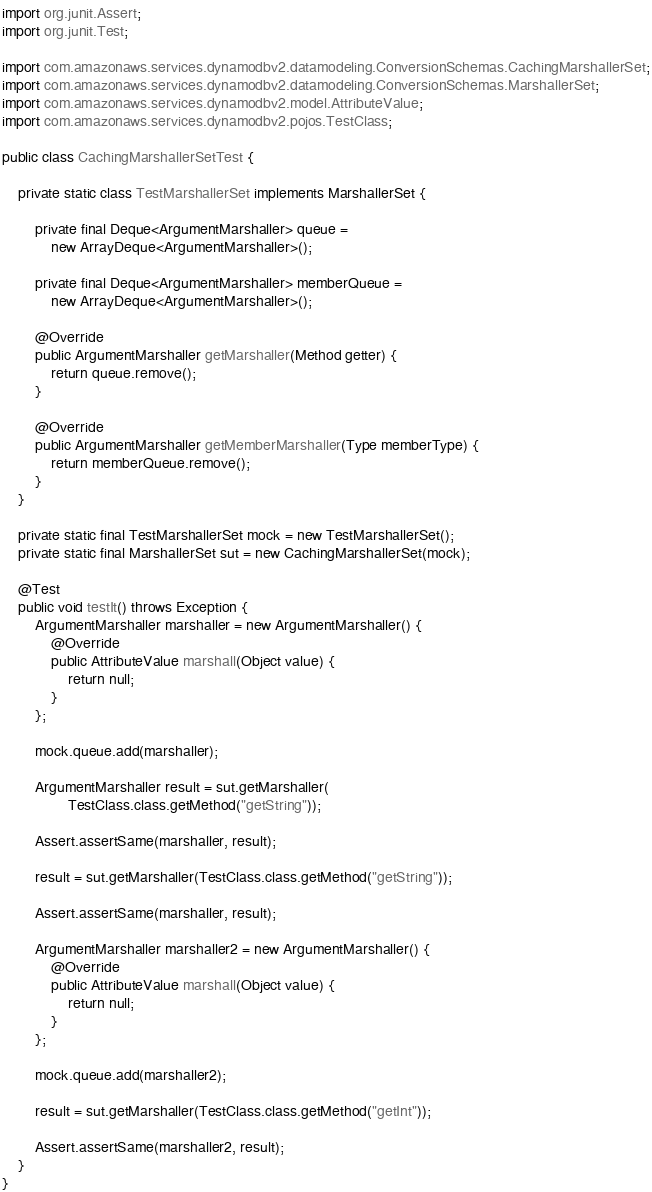<code> <loc_0><loc_0><loc_500><loc_500><_Java_>
import org.junit.Assert;
import org.junit.Test;

import com.amazonaws.services.dynamodbv2.datamodeling.ConversionSchemas.CachingMarshallerSet;
import com.amazonaws.services.dynamodbv2.datamodeling.ConversionSchemas.MarshallerSet;
import com.amazonaws.services.dynamodbv2.model.AttributeValue;
import com.amazonaws.services.dynamodbv2.pojos.TestClass;

public class CachingMarshallerSetTest {

    private static class TestMarshallerSet implements MarshallerSet {

        private final Deque<ArgumentMarshaller> queue =
            new ArrayDeque<ArgumentMarshaller>();

        private final Deque<ArgumentMarshaller> memberQueue =
            new ArrayDeque<ArgumentMarshaller>();

        @Override
        public ArgumentMarshaller getMarshaller(Method getter) {
            return queue.remove();
        }

        @Override
        public ArgumentMarshaller getMemberMarshaller(Type memberType) {
            return memberQueue.remove();
        }
    }

    private static final TestMarshallerSet mock = new TestMarshallerSet();
    private static final MarshallerSet sut = new CachingMarshallerSet(mock);

    @Test
    public void testIt() throws Exception {
        ArgumentMarshaller marshaller = new ArgumentMarshaller() {
            @Override
            public AttributeValue marshall(Object value) {
                return null;
            }
        };

        mock.queue.add(marshaller);

        ArgumentMarshaller result = sut.getMarshaller(
                TestClass.class.getMethod("getString"));

        Assert.assertSame(marshaller, result);

        result = sut.getMarshaller(TestClass.class.getMethod("getString"));

        Assert.assertSame(marshaller, result);

        ArgumentMarshaller marshaller2 = new ArgumentMarshaller() {
            @Override
            public AttributeValue marshall(Object value) {
                return null;
            }
        };

        mock.queue.add(marshaller2);

        result = sut.getMarshaller(TestClass.class.getMethod("getInt"));

        Assert.assertSame(marshaller2, result);
    }
}
</code> 